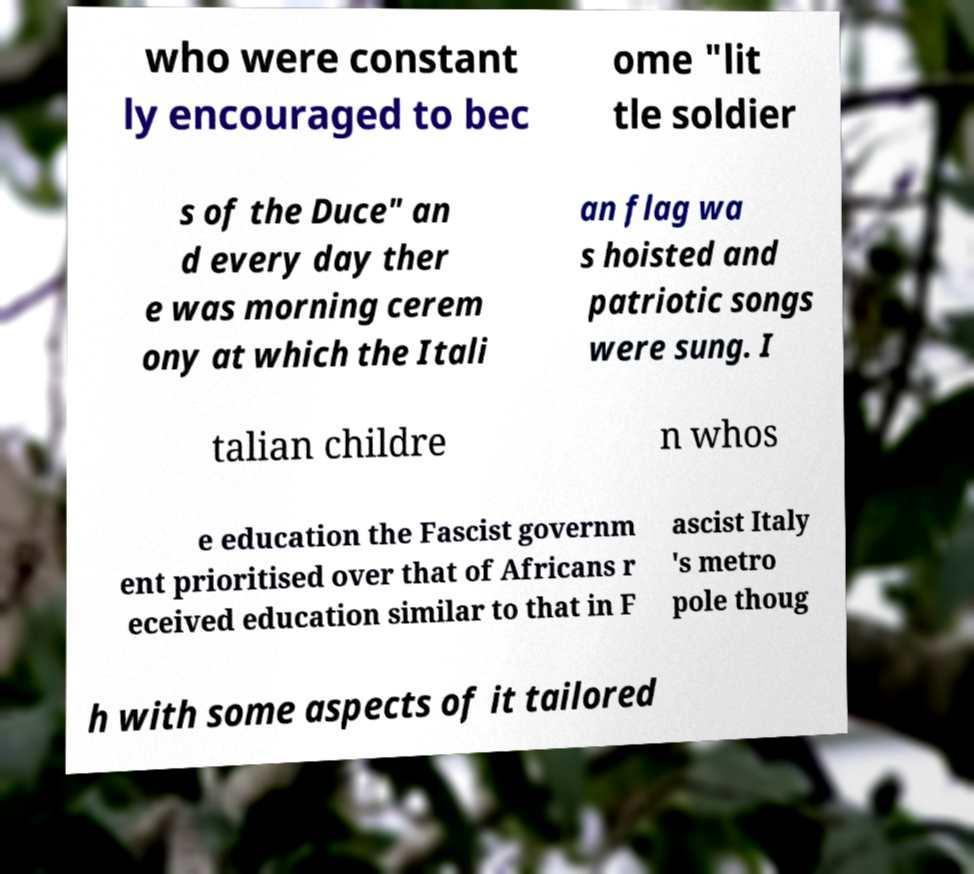What messages or text are displayed in this image? I need them in a readable, typed format. who were constant ly encouraged to bec ome "lit tle soldier s of the Duce" an d every day ther e was morning cerem ony at which the Itali an flag wa s hoisted and patriotic songs were sung. I talian childre n whos e education the Fascist governm ent prioritised over that of Africans r eceived education similar to that in F ascist Italy 's metro pole thoug h with some aspects of it tailored 